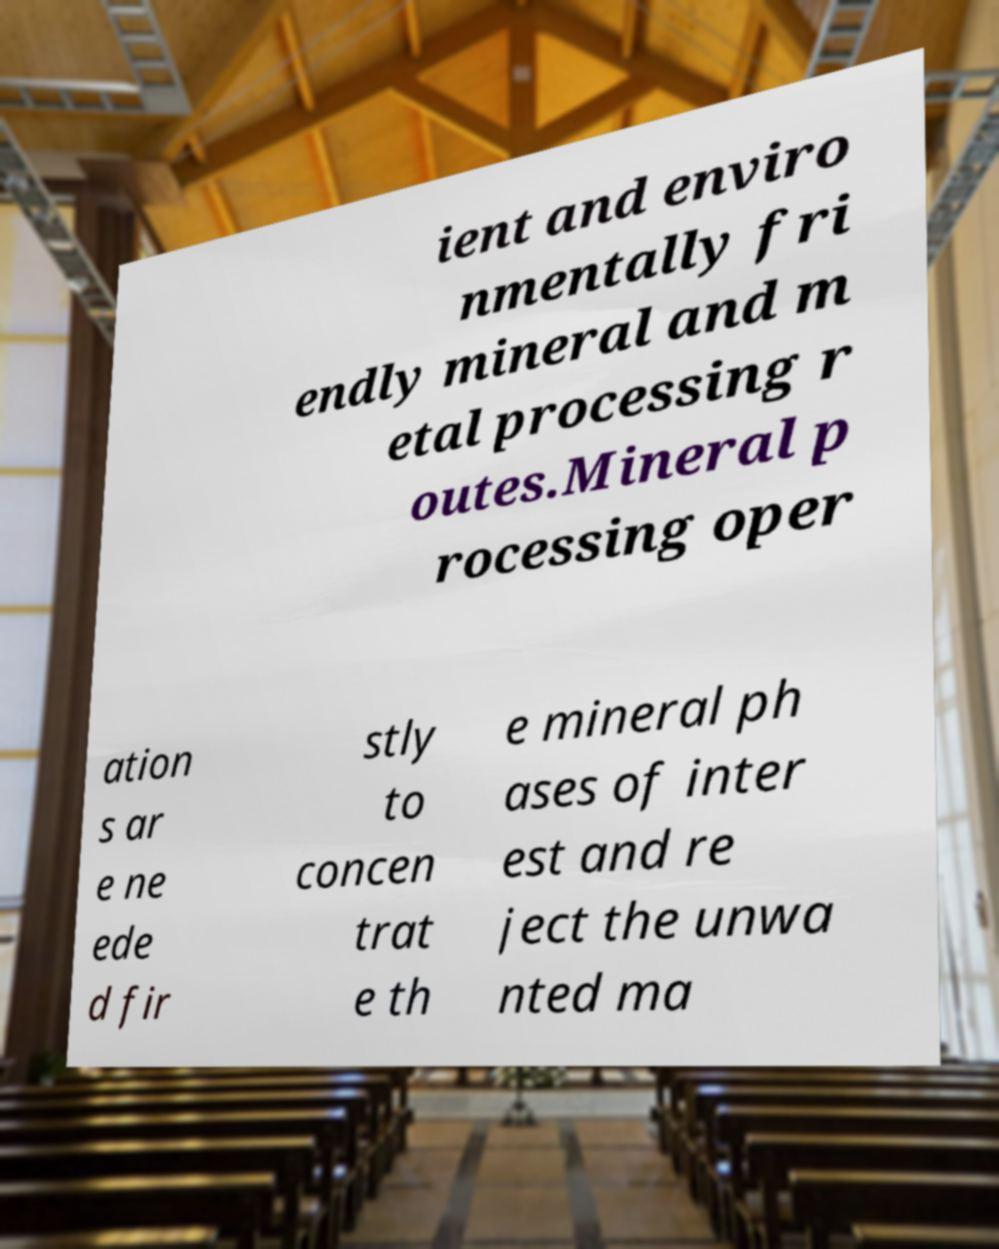Could you assist in decoding the text presented in this image and type it out clearly? ient and enviro nmentally fri endly mineral and m etal processing r outes.Mineral p rocessing oper ation s ar e ne ede d fir stly to concen trat e th e mineral ph ases of inter est and re ject the unwa nted ma 